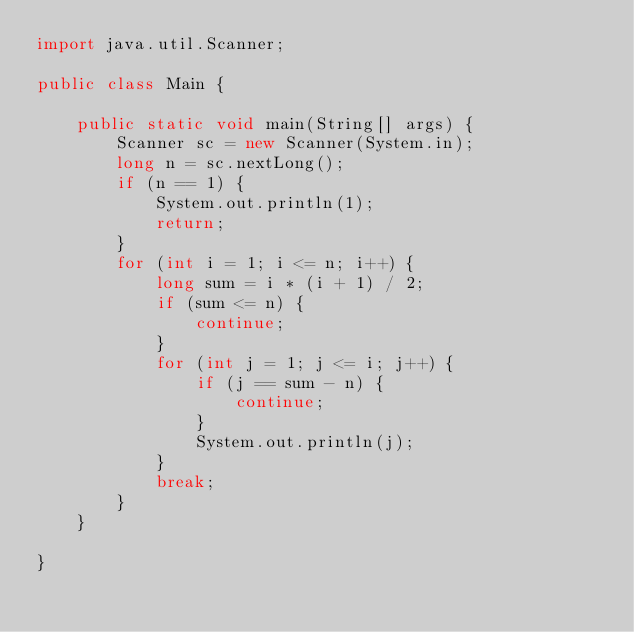Convert code to text. <code><loc_0><loc_0><loc_500><loc_500><_Java_>import java.util.Scanner;

public class Main {

    public static void main(String[] args) {
        Scanner sc = new Scanner(System.in);
        long n = sc.nextLong();
        if (n == 1) {
            System.out.println(1);
            return;
        }
        for (int i = 1; i <= n; i++) {
            long sum = i * (i + 1) / 2;
            if (sum <= n) {
                continue;
            }
            for (int j = 1; j <= i; j++) {
                if (j == sum - n) {
                    continue;
                }
                System.out.println(j);
            }
            break;
        }
    }

}
</code> 